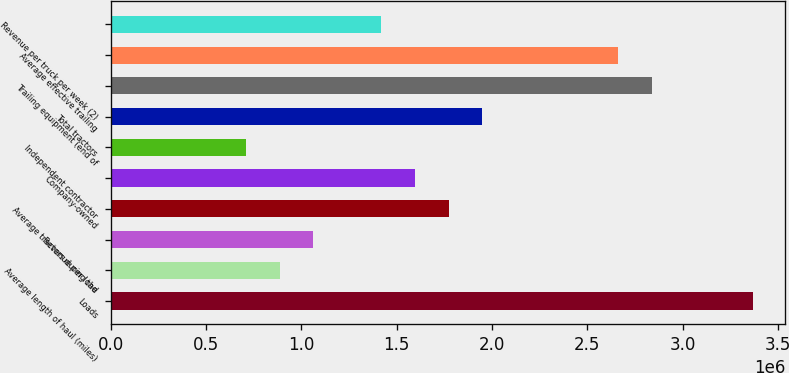Convert chart to OTSL. <chart><loc_0><loc_0><loc_500><loc_500><bar_chart><fcel>Loads<fcel>Average length of haul (miles)<fcel>Revenue per load<fcel>Average tractors during the<fcel>Company-owned<fcel>Independent contractor<fcel>Total tractors<fcel>Trailing equipment (end of<fcel>Average effective trailing<fcel>Revenue per truck per week (2)<nl><fcel>3.36832e+06<fcel>886412<fcel>1.06369e+06<fcel>1.77281e+06<fcel>1.59553e+06<fcel>709132<fcel>1.95009e+06<fcel>2.83648e+06<fcel>2.6592e+06<fcel>1.41825e+06<nl></chart> 